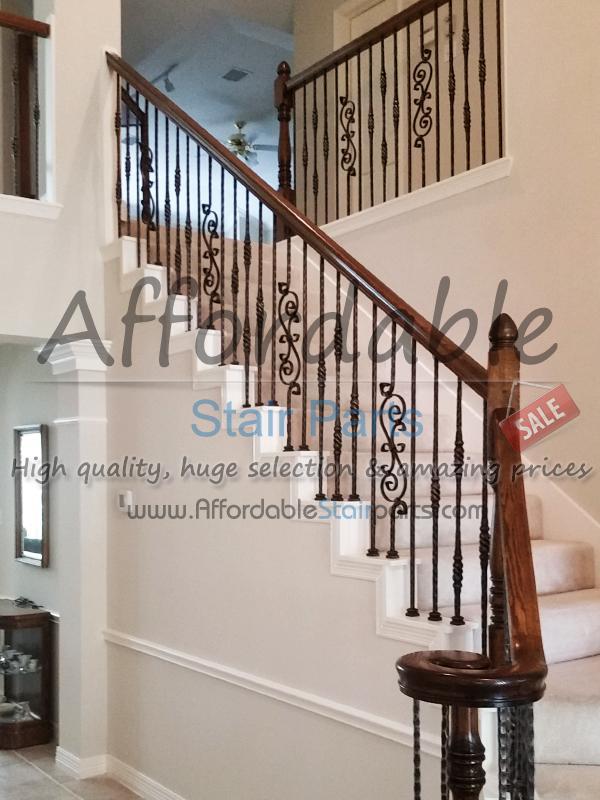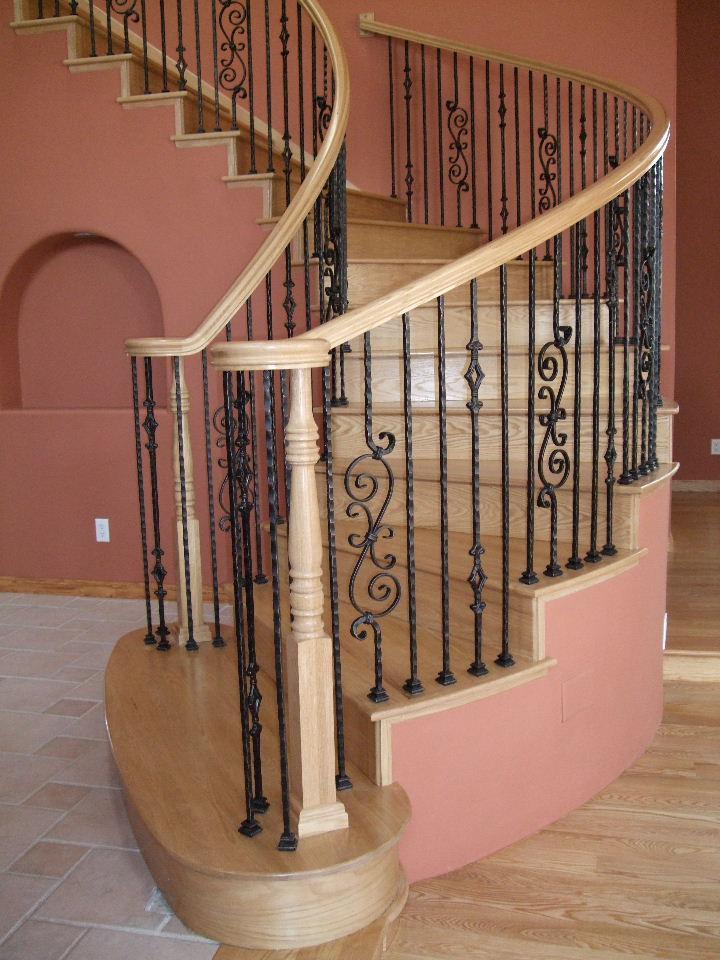The first image is the image on the left, the second image is the image on the right. Assess this claim about the two images: "The right image shows a curved staircase with a brown wood handrail and black wrought iron bars with a scroll embellishment.". Correct or not? Answer yes or no. Yes. The first image is the image on the left, the second image is the image on the right. For the images shown, is this caption "The staircase in the image on the right winds down in a circular fashion." true? Answer yes or no. Yes. 